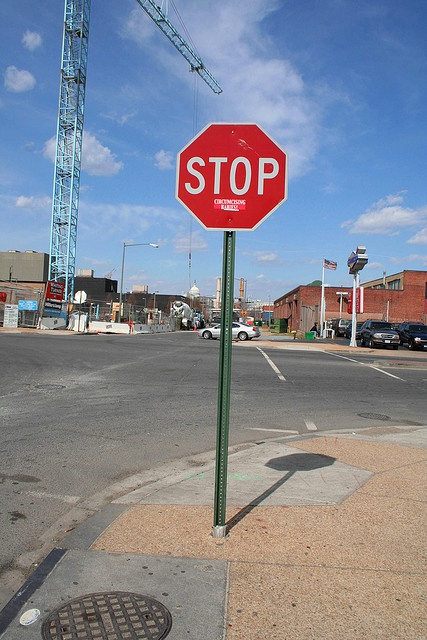Describe the objects in this image and their specific colors. I can see stop sign in gray, brown, lightgray, and lightblue tones, car in gray, black, and darkgray tones, car in gray, black, navy, and blue tones, car in gray, white, darkgray, and black tones, and car in gray, black, darkgray, and purple tones in this image. 